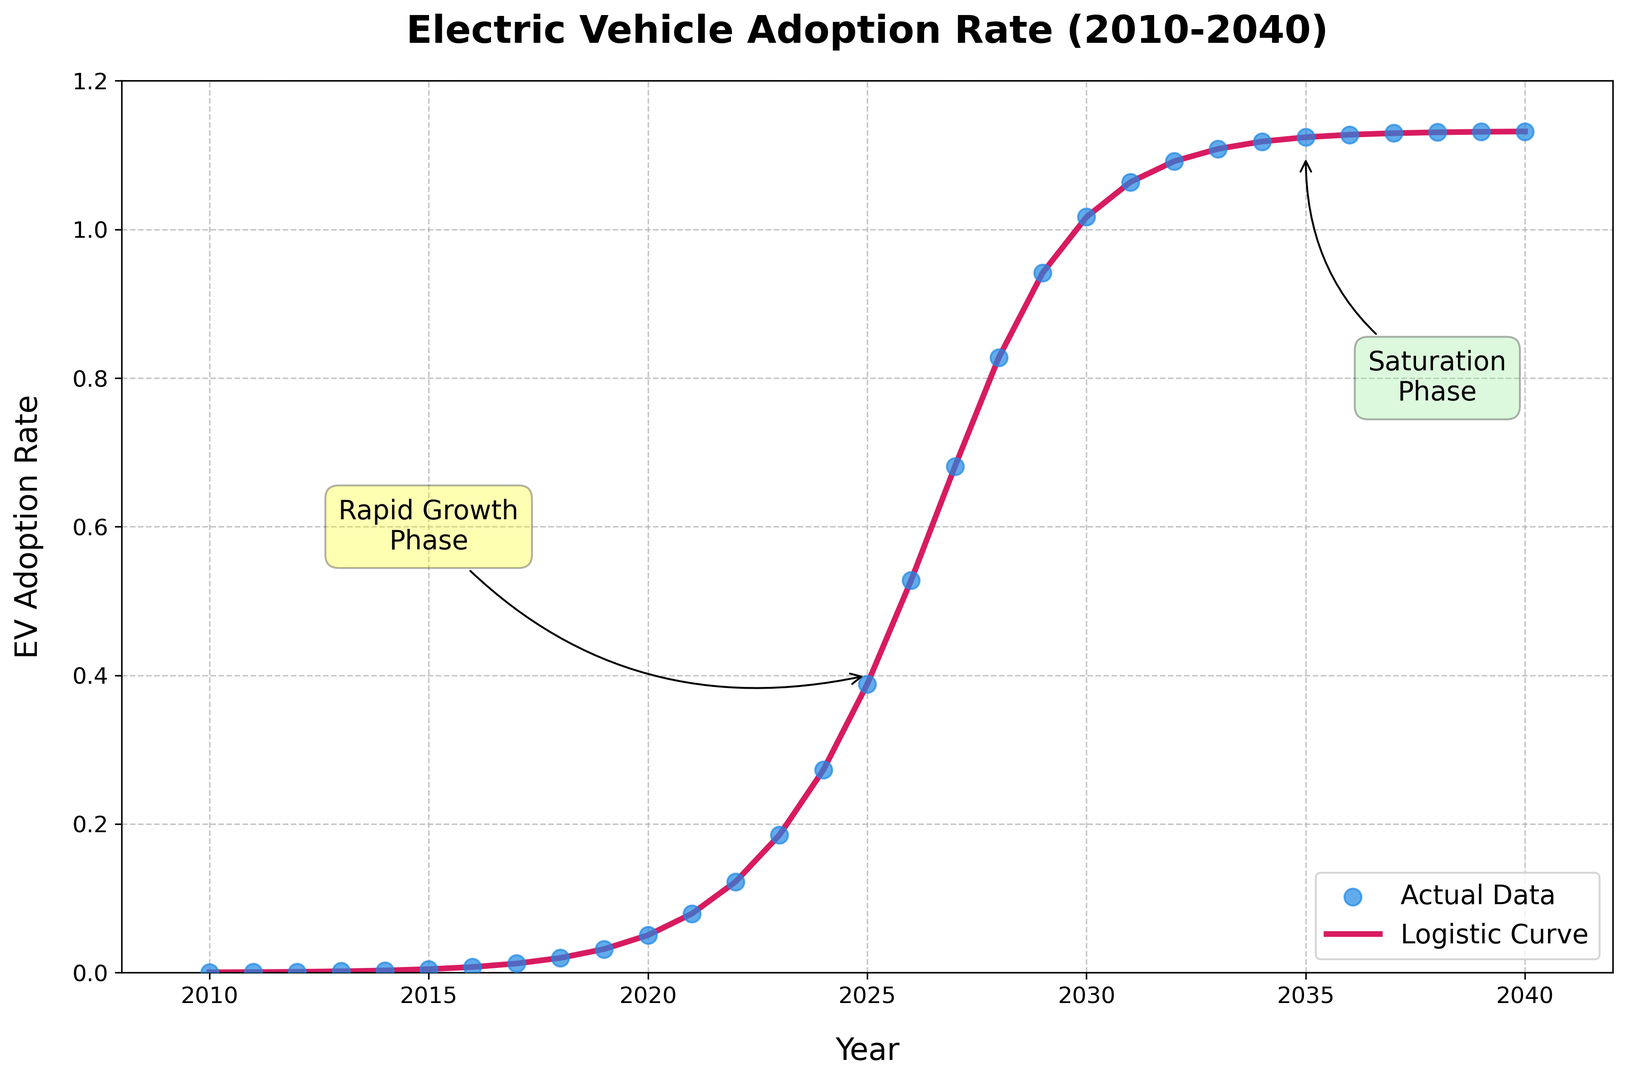Which year marks the beginning of the rapid growth phase in EV adoption? The annotation labeled 'Rapid Growth Phase' points to the year 2025 on the plot. This suggests that the rapid growth phase starts around this time.
Answer: 2025 At what year does the EV adoption rate exceed 50%? By examining the plot's y-axis and following the curve, the EV adoption rate exceeds 0.50 at around 2026.
Answer: 2026 What is the EV adoption rate in 2030? The y-axis directly on the plot shows the EV adoption rate for the year 2030. It is approximately 1.02 (or 102%).
Answer: 1.02 Compare the EV adoption rates in 2020 and 2025. In 2020, the adoption rate is about 0.0504, and in 2025, it is around 0.3881. Comparing these, 2025 has a significantly higher adoption rate.
Answer: 2025 has a higher adoption rate What can be observed about the adoption rate trend after 2035? The annotation labeled 'Saturation Phase' and the flattening curve indicate that after 2035, the EV adoption rate increases very slowly, reaching saturation.
Answer: Reaches saturation How many years does it take for the adoption rate to grow from approximately 0.1 to 1.0? Around 2020, the adoption rate is about 0.05, and by 2030, it reaches about 1.02. Therefore, it takes approximately 10 years.
Answer: 10 years Describe the color difference between the data points and the logistic curve. Data points are plotted in a blue color, and the logistic curve is represented in red.
Answer: Blue points, Red curve Which phase begins around 2027 according to the annotations, and what is the adoption rate at that point? The 'Rapid Growth Phase' annotation shifts towards the 'Saturation Phase' annotation around 2027 when the adoption rate is nearing 0.6811.
Answer: Rapid Growth Phase, nearing Saturation Phase When does the curve start to flatten out? The curve starts to visibly flatten out around 2035, as indicated by both the saturation phase annotation and the decreasing slope of the curve.
Answer: Around 2035 